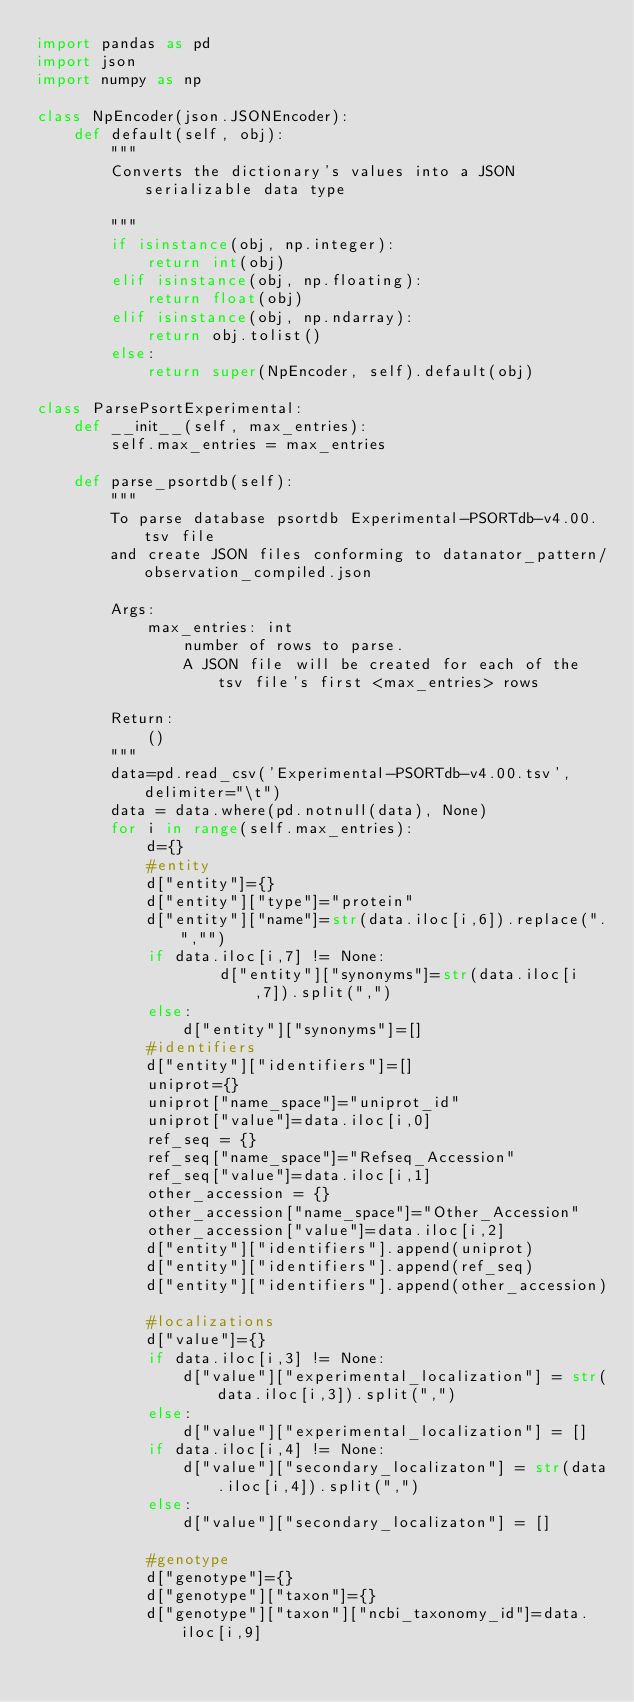<code> <loc_0><loc_0><loc_500><loc_500><_Python_>import pandas as pd
import json
import numpy as np

class NpEncoder(json.JSONEncoder):
    def default(self, obj):
        """
        Converts the dictionary's values into a JSON serializable data type
        
        """
        if isinstance(obj, np.integer):
            return int(obj)
        elif isinstance(obj, np.floating):
            return float(obj)
        elif isinstance(obj, np.ndarray):
            return obj.tolist()
        else:
            return super(NpEncoder, self).default(obj)
        
class ParsePsortExperimental:
    def __init__(self, max_entries):
        self.max_entries = max_entries

    def parse_psortdb(self):
        """
        To parse database psortdb Experimental-PSORTdb-v4.00.tsv file
        and create JSON files conforming to datanator_pattern/observation_compiled.json

        Args:
            max_entries: int
                number of rows to parse.
                A JSON file will be created for each of the tsv file's first <max_entries> rows

        Return:
            ()
        """
        data=pd.read_csv('Experimental-PSORTdb-v4.00.tsv',delimiter="\t")
        data = data.where(pd.notnull(data), None)
        for i in range(self.max_entries):
            d={}
            #entity
            d["entity"]={}
            d["entity"]["type"]="protein"
            d["entity"]["name"]=str(data.iloc[i,6]).replace(".","")
            if data.iloc[i,7] != None:
                    d["entity"]["synonyms"]=str(data.iloc[i,7]).split(",")
            else:
                d["entity"]["synonyms"]=[]
            #identifiers
            d["entity"]["identifiers"]=[]
            uniprot={}
            uniprot["name_space"]="uniprot_id"
            uniprot["value"]=data.iloc[i,0]
            ref_seq = {}
            ref_seq["name_space"]="Refseq_Accession"
            ref_seq["value"]=data.iloc[i,1]
            other_accession = {}
            other_accession["name_space"]="Other_Accession"
            other_accession["value"]=data.iloc[i,2]
            d["entity"]["identifiers"].append(uniprot)
            d["entity"]["identifiers"].append(ref_seq)
            d["entity"]["identifiers"].append(other_accession)

            #localizations
            d["value"]={}
            if data.iloc[i,3] != None:
                d["value"]["experimental_localization"] = str(data.iloc[i,3]).split(",")
            else:
                d["value"]["experimental_localization"] = []
            if data.iloc[i,4] != None:
                d["value"]["secondary_localizaton"] = str(data.iloc[i,4]).split(",")
            else:
                d["value"]["secondary_localizaton"] = []

            #genotype
            d["genotype"]={}
            d["genotype"]["taxon"]={}
            d["genotype"]["taxon"]["ncbi_taxonomy_id"]=data.iloc[i,9]</code> 